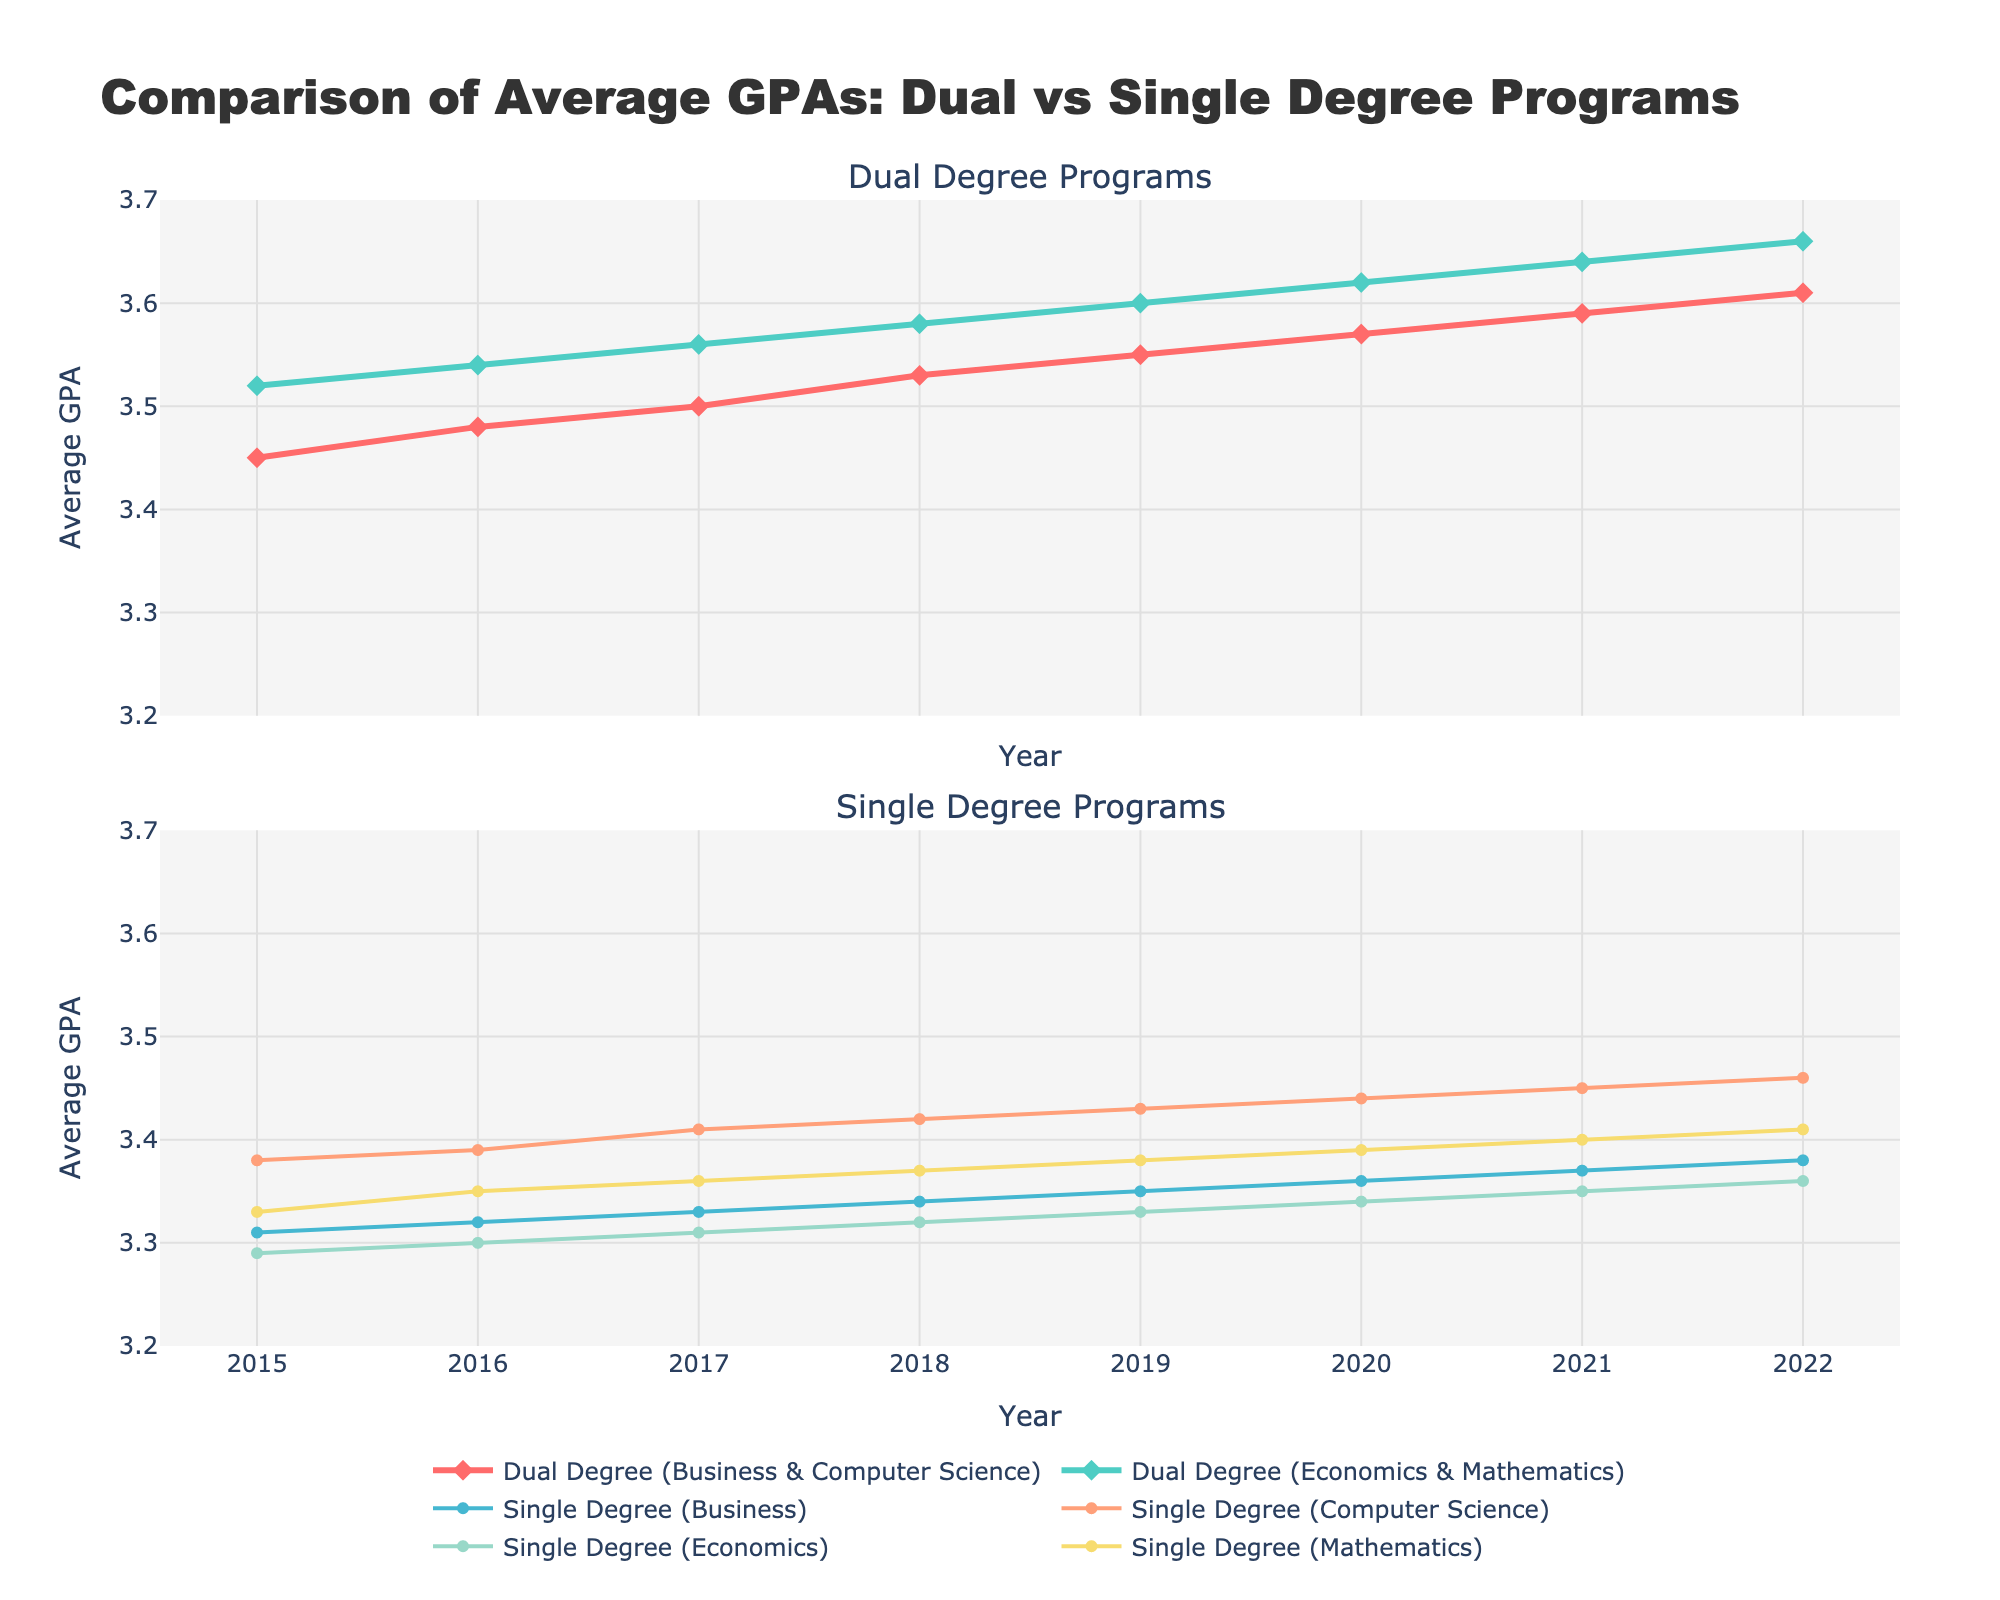What is the highest average GPA for dual degree (Economics & Mathematics) over the years? Look at the line representing dual degree (Economics & Mathematics) in the top subplot. The highest point in this line is at the year 2022 with a value of 3.66.
Answer: 3.66 What year did single degree (Computer Science) first exceed an average GPA of 3.40? Refer to the line representing single degree (Computer Science) in the bottom subplot. The GPA exceeds 3.40 for the first time in the year 2017.
Answer: 2017 Which degree program had the lowest average GPA in 2015? In the year 2015, compare the starting points for all lines. The lowest line is for single degree (Economics) with a GPA of 3.29.
Answer: Single Degree (Economics) How much did the average GPA for dual degree (Business & Computer Science) increase from 2015 to 2022? Refer to the two endpoints of the dual degree (Business & Computer Science) line in the top subplot. In 2015, the GPA is 3.45, and in 2022 it is 3.61. The increase is 3.61 - 3.45 = 0.16.
Answer: 0.16 Was there any year where the average GPA for single degree (Mathematics) did not increase compared to the previous year? Check the line for single degree (Mathematics) in the bottom subplot. Compare the GPA year-to-year: - From 2015 to 2016: 3.33 to 3.35 (increase) - From 2016 to 2017: 3.35 to 3.36 (increase) - From 2017 to 2018: 3.36 to 3.37 (increase) - From 2018 to 2019: 3.37 to 3.38 (increase) - From 2019 to 2020: 3.38 to 3.39 (increase) - From 2020 to 2021: 3.39 to 3.40 (increase) - From 2021 to 2022: 3.40 to 3.41 (increase) Each year shows an increase, so there wasn’t a year where it did not increase.
Answer: No Which degree program shows the most consistent increase over the years? Look for the line that has a smooth and steady upward trend without any fluctuations. Dual degree (Economics & Mathematics) shows the most consistent increase from 3.52 in 2015 to 3.66 in 2022.
Answer: Dual Degree (Economics & Mathematics) Compare the average GPA for single degree (Business) and dual degree (Business & Computer Science) in 2018. Which one is higher? Refer to the year 2018 in both subplots. For single degree (Business), the GPA is 3.34. For dual degree (Business & Computer Science), the GPA is 3.53. Therefore, dual degree (Business & Computer Science) is higher.
Answer: Dual Degree (Business & Computer Science) By how much has the average GPA for single degree (Economics) changed from 2019 to 2022? Compare the values for single degree (Economics) in 2019 and 2022. In 2019, the GPA is 3.33, and in 2022, it is 3.36. Calculate the change: 3.36 - 3.33 = 0.03.
Answer: 0.03 Which single degree program had the steepest increase in average GPA from 2021 to 2022? Compare the slopes of the lines for the single degree programs between 2021 and 2022. The line for single degree (Mathematics) has the steepest increase from 3.40 to 3.41.
Answer: Single Degree (Mathematics) What is the average GPA of dual degree (Business & Computer Science) and dual degree (Economics & Mathematics) in 2020? Find the 2020 values for both dual degree programs. Dual degree (Business & Computer Science) is 3.57 and dual degree (Economics & Mathematics) is 3.62. Calculate the average: (3.57 + 3.62) / 2 = 3.595.
Answer: 3.595 